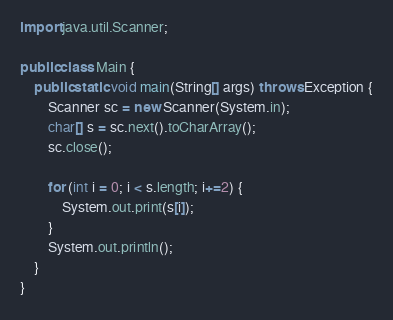<code> <loc_0><loc_0><loc_500><loc_500><_Java_>import java.util.Scanner;

public class Main {
	public static void main(String[] args) throws Exception {
		Scanner sc = new Scanner(System.in);
		char[] s = sc.next().toCharArray();
		sc.close();

		for (int i = 0; i < s.length; i+=2) {
			System.out.print(s[i]);
		}
		System.out.println();
	}
}
</code> 